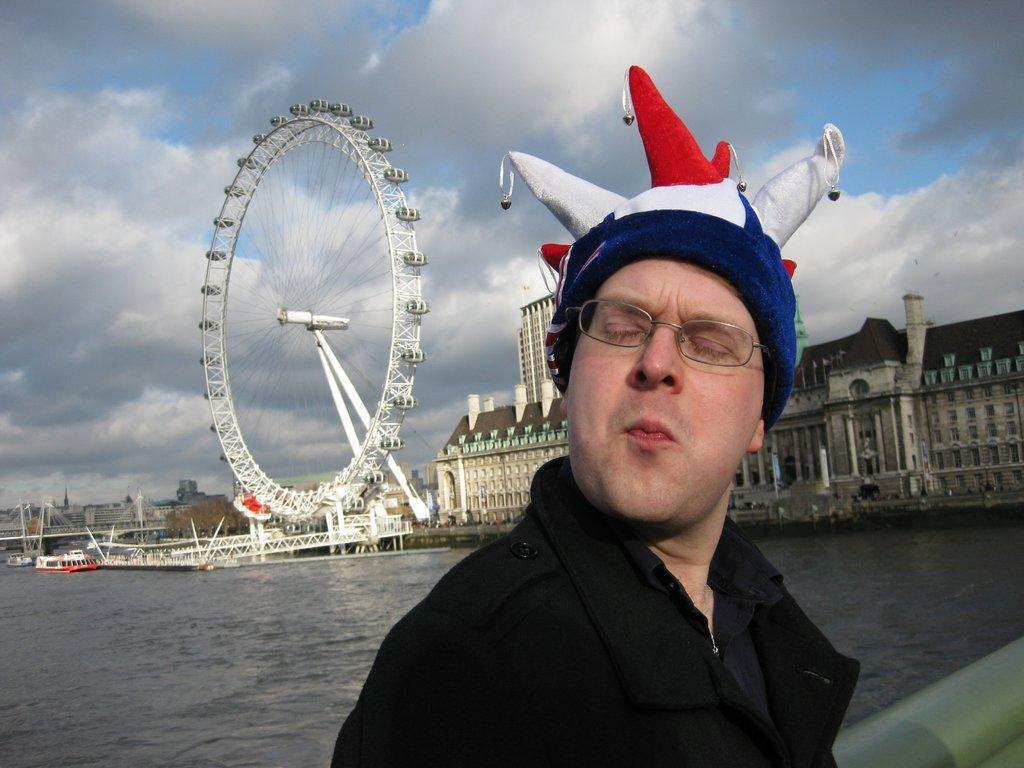In one or two sentences, can you explain what this image depicts? In this image, in the middle, i can see a man wearing a black color dress and keeping cap. In the background, we can see a building, water in a lake and few boats which are drowning in the water, giant, wheel, trees. At the top, we can see a sky which is a bit cloudy, at the bottom, we can see water. In the right corner, we can also see a metal rod. 